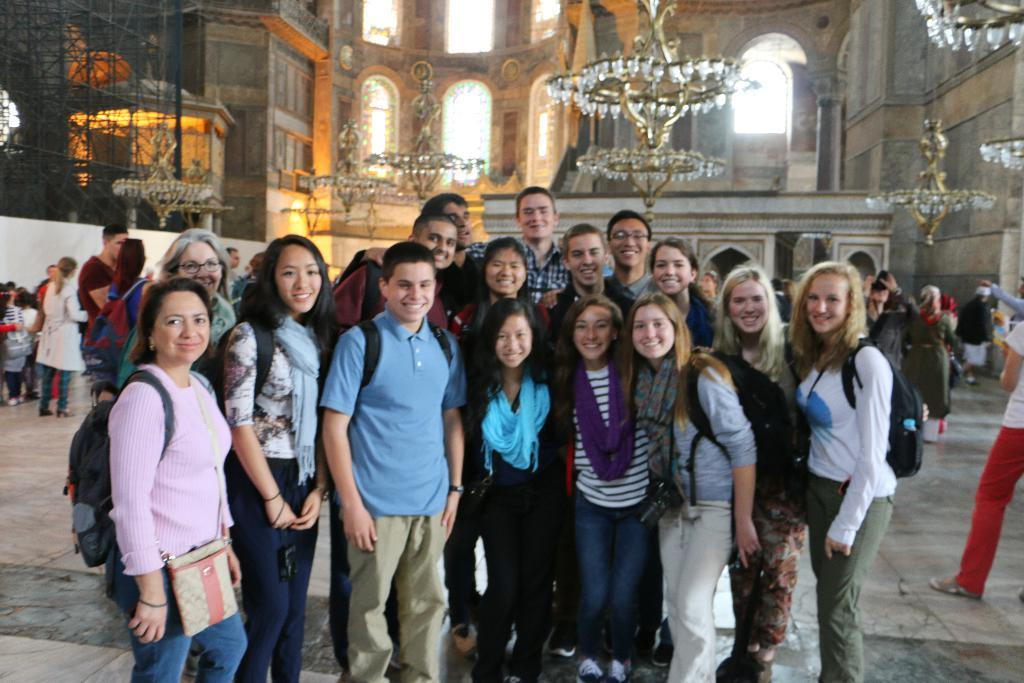How many people are in the image? There is a group of people in the image. What are the people in the image doing? The people are standing and smiling. What can be seen in the background of the image? There are chandeliers, a building, people, and windows in the background of the image. How many holes can be seen in the image? There are no holes visible in the image. What type of cracker is being passed around in the image? There is no cracker present in the image. 